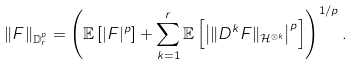Convert formula to latex. <formula><loc_0><loc_0><loc_500><loc_500>\| F \| _ { \mathbb { D } _ { r } ^ { p } } = \left ( \mathbb { E } \left [ | F | ^ { p } \right ] + \sum _ { k = 1 } ^ { r } \mathbb { E } \left [ \left | \| D ^ { k } F \| _ { \mathcal { H } ^ { \otimes k } } \right | ^ { p } \right ] \right ) ^ { 1 / p } .</formula> 